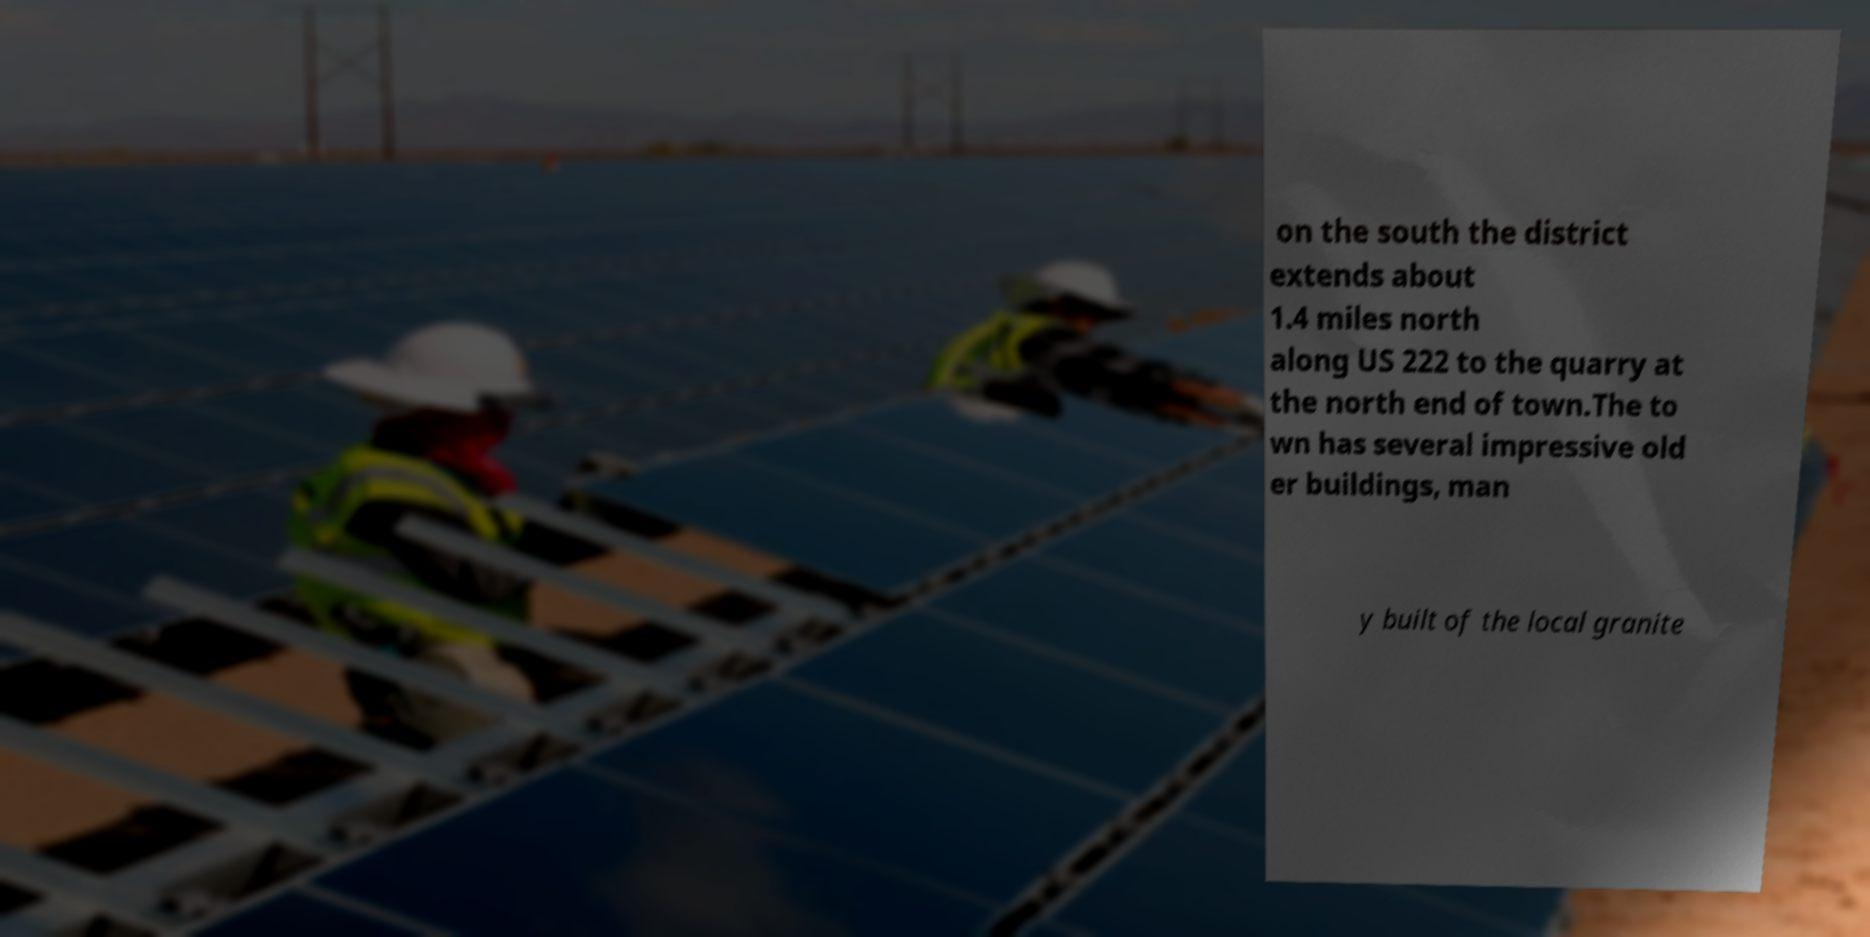I need the written content from this picture converted into text. Can you do that? on the south the district extends about 1.4 miles north along US 222 to the quarry at the north end of town.The to wn has several impressive old er buildings, man y built of the local granite 